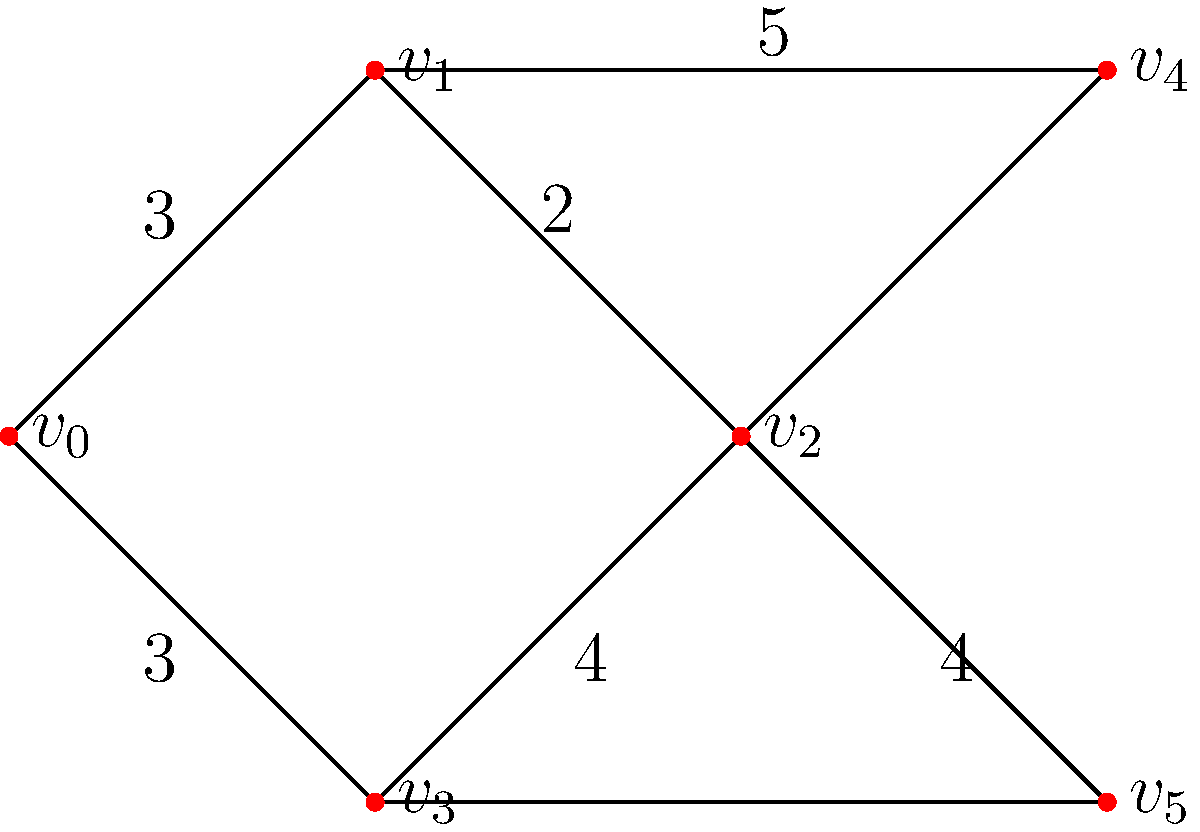As a community organizer, you're tasked with finding the most central location for a new community center. The graph represents the street network of your neighborhood, where vertices are intersections and edges are streets. Edge weights represent the distance between intersections in blocks. Which vertex has the lowest total distance to all other vertices, making it the best location for the community center? To find the most central location, we need to calculate the total distance from each vertex to all other vertices. This is known as the vertex's "closeness centrality." The vertex with the lowest total distance is the most central.

Let's calculate the shortest path distances from each vertex to all others:

1. From $v_0$:
   To $v_1$: 3
   To $v_2$: 5 (through $v_1$)
   To $v_3$: 3
   To $v_4$: 8 (through $v_1$)
   To $v_5$: 7 (through $v_3$)
   Total: 26

2. From $v_1$:
   To $v_0$: 3
   To $v_2$: 2
   To $v_3$: 5 (through $v_0$ or $v_2$)
   To $v_4$: 5
   To $v_5$: 6 (through $v_2$)
   Total: 21

3. From $v_2$:
   To $v_0$: 5 (through $v_1$)
   To $v_1$: 2
   To $v_3$: 4
   To $v_4$: 7 (through $v_1$)
   To $v_5$: 4
   Total: 22

4. From $v_3$:
   To $v_0$: 3
   To $v_1$: 5 (through $v_0$ or $v_2$)
   To $v_2$: 4
   To $v_4$: 10 (through $v_2$ and $v_1$)
   To $v_5$: 4
   Total: 26

5. From $v_4$:
   To $v_0$: 8 (through $v_1$)
   To $v_1$: 5
   To $v_2$: 7 (through $v_1$)
   To $v_3$: 10 (through $v_1$ and $v_2$)
   To $v_5$: 11 (through $v_1$ and $v_2$)
   Total: 41

6. From $v_5$:
   To $v_0$: 7 (through $v_3$)
   To $v_1$: 6 (through $v_2$)
   To $v_2$: 4
   To $v_3$: 4
   To $v_4$: 11 (through $v_2$ and $v_1$)
   Total: 32

The vertex with the lowest total distance is $v_1$ with a total distance of 21.
Answer: $v_1$ 